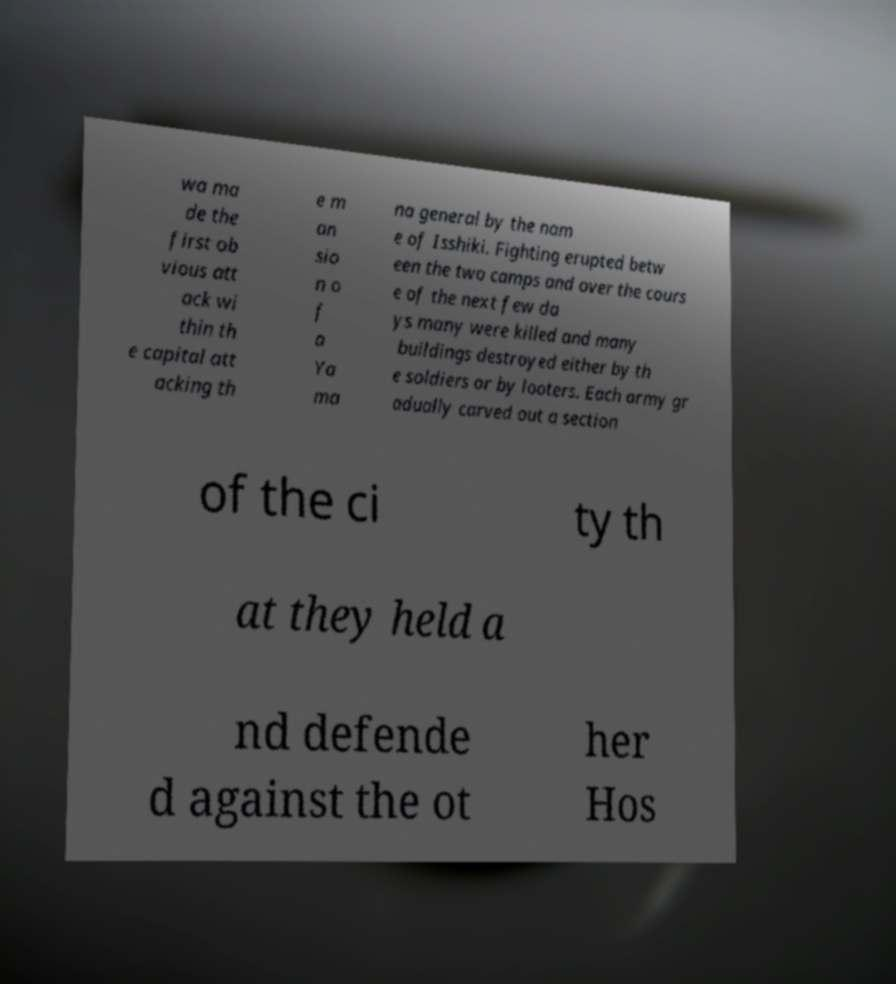For documentation purposes, I need the text within this image transcribed. Could you provide that? wa ma de the first ob vious att ack wi thin th e capital att acking th e m an sio n o f a Ya ma na general by the nam e of Isshiki. Fighting erupted betw een the two camps and over the cours e of the next few da ys many were killed and many buildings destroyed either by th e soldiers or by looters. Each army gr adually carved out a section of the ci ty th at they held a nd defende d against the ot her Hos 